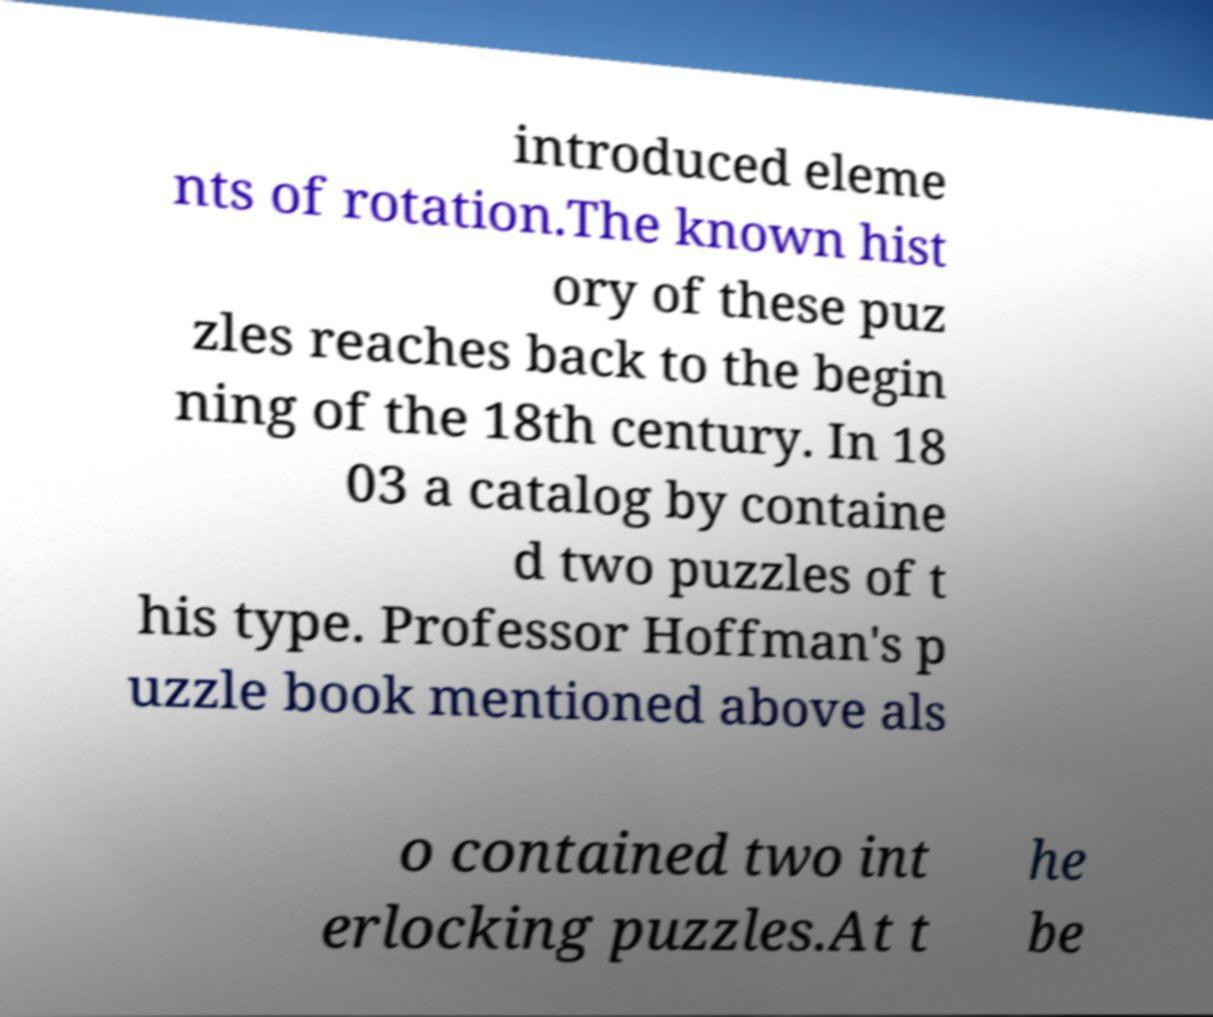Please identify and transcribe the text found in this image. introduced eleme nts of rotation.The known hist ory of these puz zles reaches back to the begin ning of the 18th century. In 18 03 a catalog by containe d two puzzles of t his type. Professor Hoffman's p uzzle book mentioned above als o contained two int erlocking puzzles.At t he be 